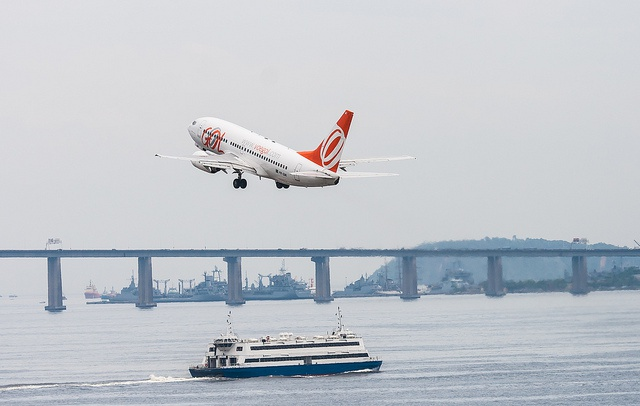Describe the objects in this image and their specific colors. I can see airplane in lightgray, darkgray, gray, and brown tones, boat in lightgray, darkblue, darkgray, and gray tones, boat in lightgray, gray, and darkgray tones, boat in lightgray, gray, and darkgray tones, and boat in lightgray, gray, and darkgray tones in this image. 